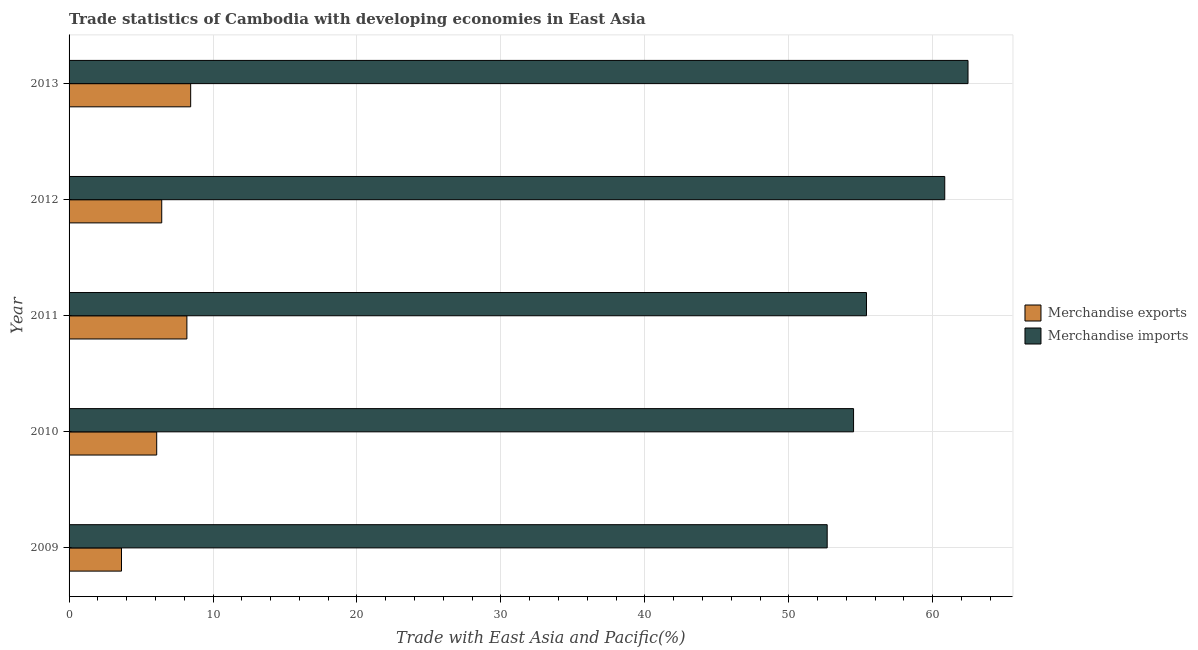How many groups of bars are there?
Provide a succinct answer. 5. Are the number of bars per tick equal to the number of legend labels?
Ensure brevity in your answer.  Yes. Are the number of bars on each tick of the Y-axis equal?
Your answer should be compact. Yes. How many bars are there on the 3rd tick from the top?
Your response must be concise. 2. How many bars are there on the 4th tick from the bottom?
Ensure brevity in your answer.  2. In how many cases, is the number of bars for a given year not equal to the number of legend labels?
Keep it short and to the point. 0. What is the merchandise exports in 2010?
Keep it short and to the point. 6.09. Across all years, what is the maximum merchandise imports?
Keep it short and to the point. 62.45. Across all years, what is the minimum merchandise imports?
Offer a very short reply. 52.67. What is the total merchandise imports in the graph?
Keep it short and to the point. 285.85. What is the difference between the merchandise imports in 2009 and that in 2010?
Your response must be concise. -1.83. What is the difference between the merchandise exports in 2009 and the merchandise imports in 2013?
Make the answer very short. -58.81. What is the average merchandise exports per year?
Provide a succinct answer. 6.56. In the year 2010, what is the difference between the merchandise imports and merchandise exports?
Ensure brevity in your answer.  48.41. In how many years, is the merchandise exports greater than 4 %?
Provide a succinct answer. 4. What is the ratio of the merchandise imports in 2011 to that in 2012?
Your answer should be compact. 0.91. Is the merchandise imports in 2009 less than that in 2010?
Keep it short and to the point. Yes. What is the difference between the highest and the second highest merchandise imports?
Offer a very short reply. 1.62. What is the difference between the highest and the lowest merchandise exports?
Your answer should be compact. 4.81. In how many years, is the merchandise imports greater than the average merchandise imports taken over all years?
Your answer should be compact. 2. Is the sum of the merchandise exports in 2010 and 2012 greater than the maximum merchandise imports across all years?
Provide a succinct answer. No. What does the 1st bar from the top in 2010 represents?
Your answer should be very brief. Merchandise imports. How many bars are there?
Give a very brief answer. 10. Are all the bars in the graph horizontal?
Make the answer very short. Yes. How are the legend labels stacked?
Your answer should be very brief. Vertical. What is the title of the graph?
Offer a very short reply. Trade statistics of Cambodia with developing economies in East Asia. Does "Fixed telephone" appear as one of the legend labels in the graph?
Give a very brief answer. No. What is the label or title of the X-axis?
Give a very brief answer. Trade with East Asia and Pacific(%). What is the label or title of the Y-axis?
Provide a succinct answer. Year. What is the Trade with East Asia and Pacific(%) of Merchandise exports in 2009?
Keep it short and to the point. 3.64. What is the Trade with East Asia and Pacific(%) of Merchandise imports in 2009?
Provide a short and direct response. 52.67. What is the Trade with East Asia and Pacific(%) of Merchandise exports in 2010?
Your answer should be compact. 6.09. What is the Trade with East Asia and Pacific(%) in Merchandise imports in 2010?
Your answer should be compact. 54.5. What is the Trade with East Asia and Pacific(%) of Merchandise exports in 2011?
Provide a short and direct response. 8.18. What is the Trade with East Asia and Pacific(%) of Merchandise imports in 2011?
Keep it short and to the point. 55.4. What is the Trade with East Asia and Pacific(%) in Merchandise exports in 2012?
Offer a terse response. 6.44. What is the Trade with East Asia and Pacific(%) of Merchandise imports in 2012?
Make the answer very short. 60.83. What is the Trade with East Asia and Pacific(%) in Merchandise exports in 2013?
Ensure brevity in your answer.  8.45. What is the Trade with East Asia and Pacific(%) of Merchandise imports in 2013?
Keep it short and to the point. 62.45. Across all years, what is the maximum Trade with East Asia and Pacific(%) of Merchandise exports?
Keep it short and to the point. 8.45. Across all years, what is the maximum Trade with East Asia and Pacific(%) in Merchandise imports?
Your answer should be compact. 62.45. Across all years, what is the minimum Trade with East Asia and Pacific(%) in Merchandise exports?
Provide a succinct answer. 3.64. Across all years, what is the minimum Trade with East Asia and Pacific(%) in Merchandise imports?
Offer a terse response. 52.67. What is the total Trade with East Asia and Pacific(%) of Merchandise exports in the graph?
Give a very brief answer. 32.8. What is the total Trade with East Asia and Pacific(%) of Merchandise imports in the graph?
Make the answer very short. 285.85. What is the difference between the Trade with East Asia and Pacific(%) in Merchandise exports in 2009 and that in 2010?
Give a very brief answer. -2.45. What is the difference between the Trade with East Asia and Pacific(%) in Merchandise imports in 2009 and that in 2010?
Provide a succinct answer. -1.83. What is the difference between the Trade with East Asia and Pacific(%) in Merchandise exports in 2009 and that in 2011?
Offer a terse response. -4.54. What is the difference between the Trade with East Asia and Pacific(%) of Merchandise imports in 2009 and that in 2011?
Make the answer very short. -2.73. What is the difference between the Trade with East Asia and Pacific(%) in Merchandise exports in 2009 and that in 2012?
Keep it short and to the point. -2.8. What is the difference between the Trade with East Asia and Pacific(%) in Merchandise imports in 2009 and that in 2012?
Provide a succinct answer. -8.17. What is the difference between the Trade with East Asia and Pacific(%) of Merchandise exports in 2009 and that in 2013?
Offer a terse response. -4.81. What is the difference between the Trade with East Asia and Pacific(%) of Merchandise imports in 2009 and that in 2013?
Your response must be concise. -9.78. What is the difference between the Trade with East Asia and Pacific(%) in Merchandise exports in 2010 and that in 2011?
Ensure brevity in your answer.  -2.1. What is the difference between the Trade with East Asia and Pacific(%) of Merchandise imports in 2010 and that in 2011?
Your response must be concise. -0.9. What is the difference between the Trade with East Asia and Pacific(%) in Merchandise exports in 2010 and that in 2012?
Give a very brief answer. -0.35. What is the difference between the Trade with East Asia and Pacific(%) of Merchandise imports in 2010 and that in 2012?
Your response must be concise. -6.33. What is the difference between the Trade with East Asia and Pacific(%) in Merchandise exports in 2010 and that in 2013?
Keep it short and to the point. -2.36. What is the difference between the Trade with East Asia and Pacific(%) in Merchandise imports in 2010 and that in 2013?
Your response must be concise. -7.95. What is the difference between the Trade with East Asia and Pacific(%) of Merchandise exports in 2011 and that in 2012?
Make the answer very short. 1.75. What is the difference between the Trade with East Asia and Pacific(%) in Merchandise imports in 2011 and that in 2012?
Offer a very short reply. -5.44. What is the difference between the Trade with East Asia and Pacific(%) of Merchandise exports in 2011 and that in 2013?
Give a very brief answer. -0.26. What is the difference between the Trade with East Asia and Pacific(%) of Merchandise imports in 2011 and that in 2013?
Keep it short and to the point. -7.05. What is the difference between the Trade with East Asia and Pacific(%) in Merchandise exports in 2012 and that in 2013?
Make the answer very short. -2.01. What is the difference between the Trade with East Asia and Pacific(%) in Merchandise imports in 2012 and that in 2013?
Give a very brief answer. -1.62. What is the difference between the Trade with East Asia and Pacific(%) in Merchandise exports in 2009 and the Trade with East Asia and Pacific(%) in Merchandise imports in 2010?
Provide a succinct answer. -50.86. What is the difference between the Trade with East Asia and Pacific(%) in Merchandise exports in 2009 and the Trade with East Asia and Pacific(%) in Merchandise imports in 2011?
Ensure brevity in your answer.  -51.75. What is the difference between the Trade with East Asia and Pacific(%) of Merchandise exports in 2009 and the Trade with East Asia and Pacific(%) of Merchandise imports in 2012?
Provide a short and direct response. -57.19. What is the difference between the Trade with East Asia and Pacific(%) of Merchandise exports in 2009 and the Trade with East Asia and Pacific(%) of Merchandise imports in 2013?
Offer a very short reply. -58.81. What is the difference between the Trade with East Asia and Pacific(%) of Merchandise exports in 2010 and the Trade with East Asia and Pacific(%) of Merchandise imports in 2011?
Keep it short and to the point. -49.31. What is the difference between the Trade with East Asia and Pacific(%) in Merchandise exports in 2010 and the Trade with East Asia and Pacific(%) in Merchandise imports in 2012?
Ensure brevity in your answer.  -54.75. What is the difference between the Trade with East Asia and Pacific(%) of Merchandise exports in 2010 and the Trade with East Asia and Pacific(%) of Merchandise imports in 2013?
Provide a short and direct response. -56.36. What is the difference between the Trade with East Asia and Pacific(%) of Merchandise exports in 2011 and the Trade with East Asia and Pacific(%) of Merchandise imports in 2012?
Provide a succinct answer. -52.65. What is the difference between the Trade with East Asia and Pacific(%) in Merchandise exports in 2011 and the Trade with East Asia and Pacific(%) in Merchandise imports in 2013?
Offer a terse response. -54.26. What is the difference between the Trade with East Asia and Pacific(%) in Merchandise exports in 2012 and the Trade with East Asia and Pacific(%) in Merchandise imports in 2013?
Offer a very short reply. -56.01. What is the average Trade with East Asia and Pacific(%) in Merchandise exports per year?
Keep it short and to the point. 6.56. What is the average Trade with East Asia and Pacific(%) in Merchandise imports per year?
Offer a very short reply. 57.17. In the year 2009, what is the difference between the Trade with East Asia and Pacific(%) of Merchandise exports and Trade with East Asia and Pacific(%) of Merchandise imports?
Give a very brief answer. -49.02. In the year 2010, what is the difference between the Trade with East Asia and Pacific(%) in Merchandise exports and Trade with East Asia and Pacific(%) in Merchandise imports?
Your answer should be compact. -48.41. In the year 2011, what is the difference between the Trade with East Asia and Pacific(%) in Merchandise exports and Trade with East Asia and Pacific(%) in Merchandise imports?
Offer a very short reply. -47.21. In the year 2012, what is the difference between the Trade with East Asia and Pacific(%) in Merchandise exports and Trade with East Asia and Pacific(%) in Merchandise imports?
Keep it short and to the point. -54.4. In the year 2013, what is the difference between the Trade with East Asia and Pacific(%) of Merchandise exports and Trade with East Asia and Pacific(%) of Merchandise imports?
Provide a succinct answer. -54. What is the ratio of the Trade with East Asia and Pacific(%) of Merchandise exports in 2009 to that in 2010?
Your response must be concise. 0.6. What is the ratio of the Trade with East Asia and Pacific(%) in Merchandise imports in 2009 to that in 2010?
Your response must be concise. 0.97. What is the ratio of the Trade with East Asia and Pacific(%) in Merchandise exports in 2009 to that in 2011?
Provide a short and direct response. 0.44. What is the ratio of the Trade with East Asia and Pacific(%) of Merchandise imports in 2009 to that in 2011?
Offer a terse response. 0.95. What is the ratio of the Trade with East Asia and Pacific(%) in Merchandise exports in 2009 to that in 2012?
Your answer should be compact. 0.57. What is the ratio of the Trade with East Asia and Pacific(%) of Merchandise imports in 2009 to that in 2012?
Offer a very short reply. 0.87. What is the ratio of the Trade with East Asia and Pacific(%) of Merchandise exports in 2009 to that in 2013?
Give a very brief answer. 0.43. What is the ratio of the Trade with East Asia and Pacific(%) of Merchandise imports in 2009 to that in 2013?
Give a very brief answer. 0.84. What is the ratio of the Trade with East Asia and Pacific(%) of Merchandise exports in 2010 to that in 2011?
Provide a short and direct response. 0.74. What is the ratio of the Trade with East Asia and Pacific(%) of Merchandise imports in 2010 to that in 2011?
Ensure brevity in your answer.  0.98. What is the ratio of the Trade with East Asia and Pacific(%) of Merchandise exports in 2010 to that in 2012?
Give a very brief answer. 0.95. What is the ratio of the Trade with East Asia and Pacific(%) in Merchandise imports in 2010 to that in 2012?
Make the answer very short. 0.9. What is the ratio of the Trade with East Asia and Pacific(%) of Merchandise exports in 2010 to that in 2013?
Provide a short and direct response. 0.72. What is the ratio of the Trade with East Asia and Pacific(%) of Merchandise imports in 2010 to that in 2013?
Your answer should be very brief. 0.87. What is the ratio of the Trade with East Asia and Pacific(%) of Merchandise exports in 2011 to that in 2012?
Offer a terse response. 1.27. What is the ratio of the Trade with East Asia and Pacific(%) in Merchandise imports in 2011 to that in 2012?
Your answer should be compact. 0.91. What is the ratio of the Trade with East Asia and Pacific(%) of Merchandise exports in 2011 to that in 2013?
Ensure brevity in your answer.  0.97. What is the ratio of the Trade with East Asia and Pacific(%) in Merchandise imports in 2011 to that in 2013?
Your response must be concise. 0.89. What is the ratio of the Trade with East Asia and Pacific(%) of Merchandise exports in 2012 to that in 2013?
Give a very brief answer. 0.76. What is the ratio of the Trade with East Asia and Pacific(%) in Merchandise imports in 2012 to that in 2013?
Your answer should be very brief. 0.97. What is the difference between the highest and the second highest Trade with East Asia and Pacific(%) in Merchandise exports?
Offer a terse response. 0.26. What is the difference between the highest and the second highest Trade with East Asia and Pacific(%) in Merchandise imports?
Your response must be concise. 1.62. What is the difference between the highest and the lowest Trade with East Asia and Pacific(%) in Merchandise exports?
Ensure brevity in your answer.  4.81. What is the difference between the highest and the lowest Trade with East Asia and Pacific(%) in Merchandise imports?
Your answer should be compact. 9.78. 